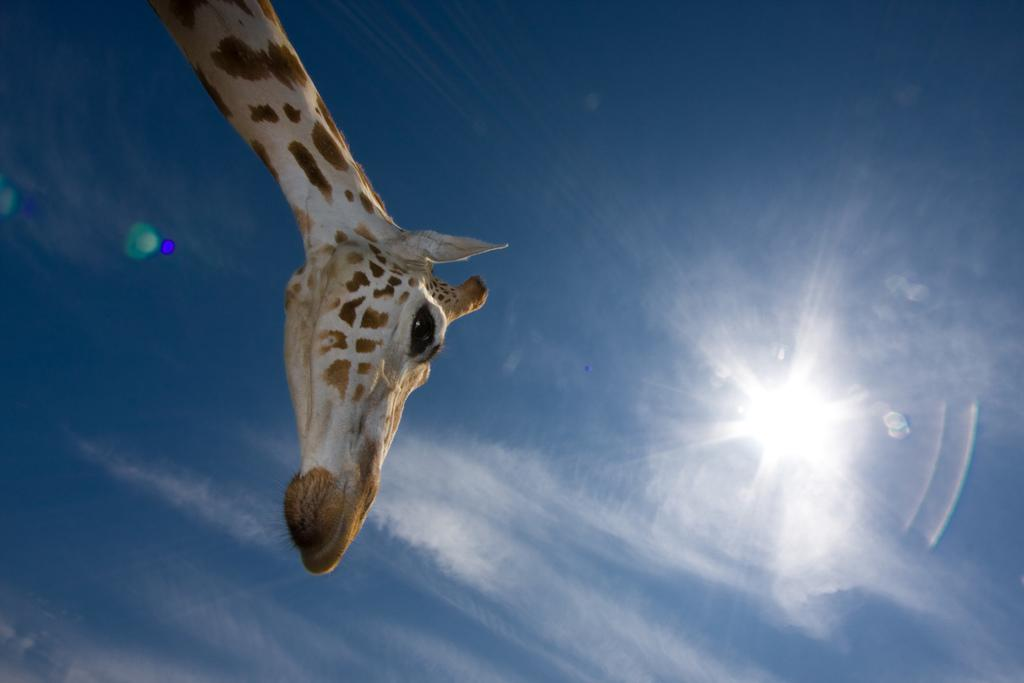What animal is present in the image? There is a giraffe in the image. What color is the sky in the background of the image? The sky is blue in the background of the image. What celestial body can be seen in the background of the image? The sun is visible in the background of the image. What type of vest is the cow wearing in the image? There is no cow or vest present in the image; it features a giraffe and a blue sky with the sun visible. 